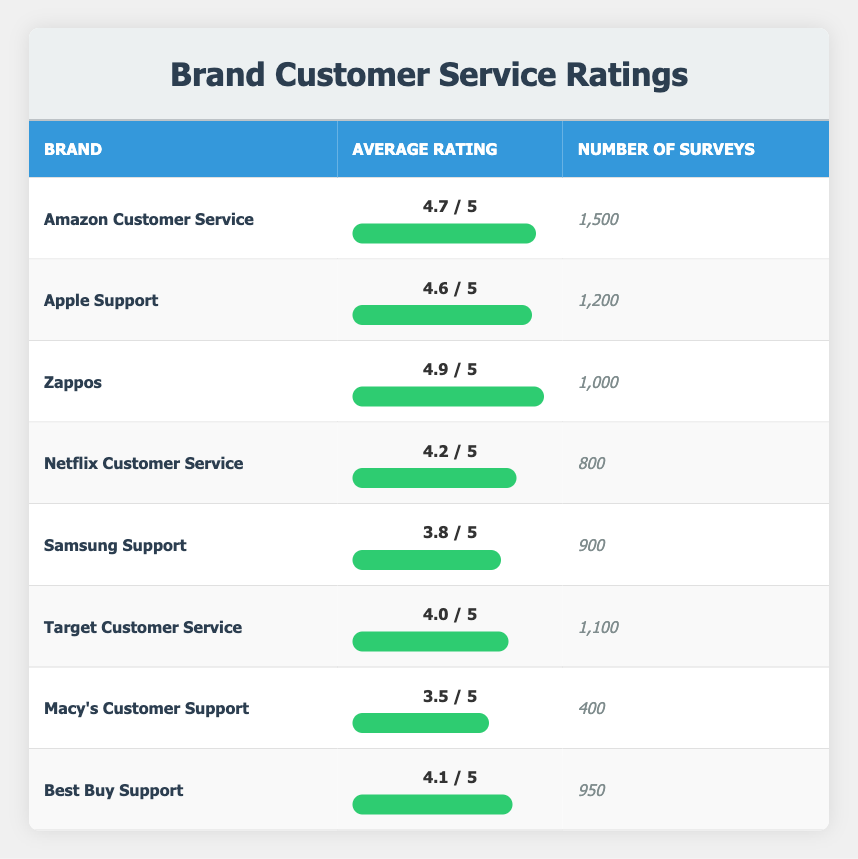What is the highest average customer satisfaction rating? The table lists the average ratings for each brand. By comparing the ratings, Zappos has the highest average rating of 4.9, which is more than any other brand listed.
Answer: 4.9 How many surveys did Amazon Customer Service receive? The table indicates that the number of surveys for Amazon Customer Service is provided under the "Number of Surveys" column. It states 1,500.
Answer: 1,500 Is Samsung Support rated higher than Macy's Customer Support? By comparing the average ratings in the table, Samsung Support has a rating of 3.8 while Macy's Customer Support has a rating of 3.5. Since 3.8 is greater than 3.5, the statement is true.
Answer: Yes What is the average rating of Target Customer Service compared to Netflix Customer Service? The average rating for Target Customer Service is 4.0, which can be found in the respective column. For Netflix Customer Service, the average rating is 4.2. Since 4.0 is less than 4.2, Target has a lower rating.
Answer: Target has a lower rating What is the combined average rating of Apple Support and Best Buy Support? The average ratings for Apple Support and Best Buy Support are 4.6 and 4.1 respectively. To find the combined average, add both ratings: 4.6 + 4.1 = 8.7. Then divide this sum by 2 to get the average: 8.7 / 2 = 4.35.
Answer: 4.35 Which brand has the lowest customer satisfaction rating? Reviewing the average ratings in the table, Macy's Customer Support has the lowest rating at 3.5 compared to all other listed brands.
Answer: Macy's Customer Support How many more surveys did Zappos receive than Netflix Customer Service? Zappos received 1,000 surveys, while Netflix Customer Service received 800 surveys. To find the difference, subtract the number of Netflix surveys from Zappos surveys: 1,000 - 800 = 200.
Answer: 200 Is the average rating of Best Buy Support higher than 4.0? The table indicates that Best Buy Support has an average rating of 4.1. Since 4.1 is higher than 4.0, the statement is true.
Answer: Yes What percentage of surveys did Zappos receive compared to Amazon Customer Service? Zappos received 1,000 surveys and Amazon Customer Service received 1,500 surveys. To find the percentage, divide Zappos surveys by Amazon surveys: (1000/1500) * 100 = 66.67%.
Answer: 66.67% 